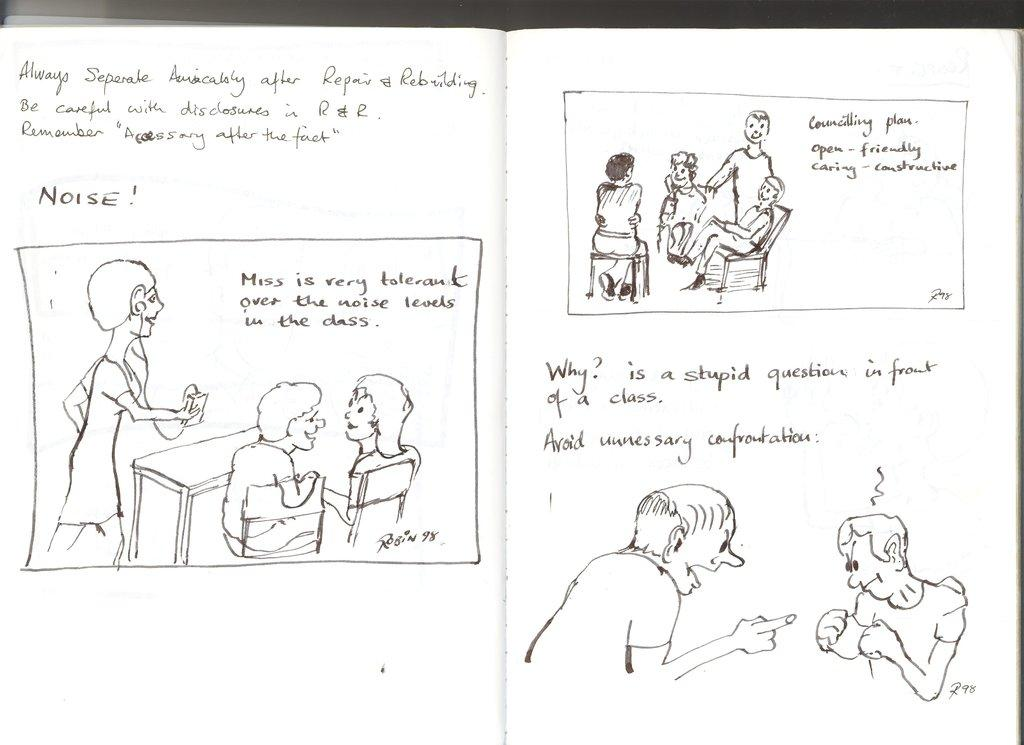What type of visual content is present in the image? There are cartoons in the image. Is there any written content in the image? Yes, there is text in the image. Where is the playground located in the image? There is no playground present in the image. What type of needle is being used in the cartoon? There are no needles present in the image, as it features cartoons and text. 